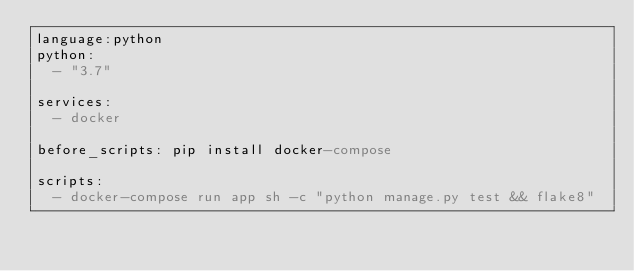<code> <loc_0><loc_0><loc_500><loc_500><_YAML_>language:python 
python:
  - "3.7"

services:
  - docker 

before_scripts: pip install docker-compose 

scripts:
  - docker-compose run app sh -c "python manage.py test && flake8"
</code> 